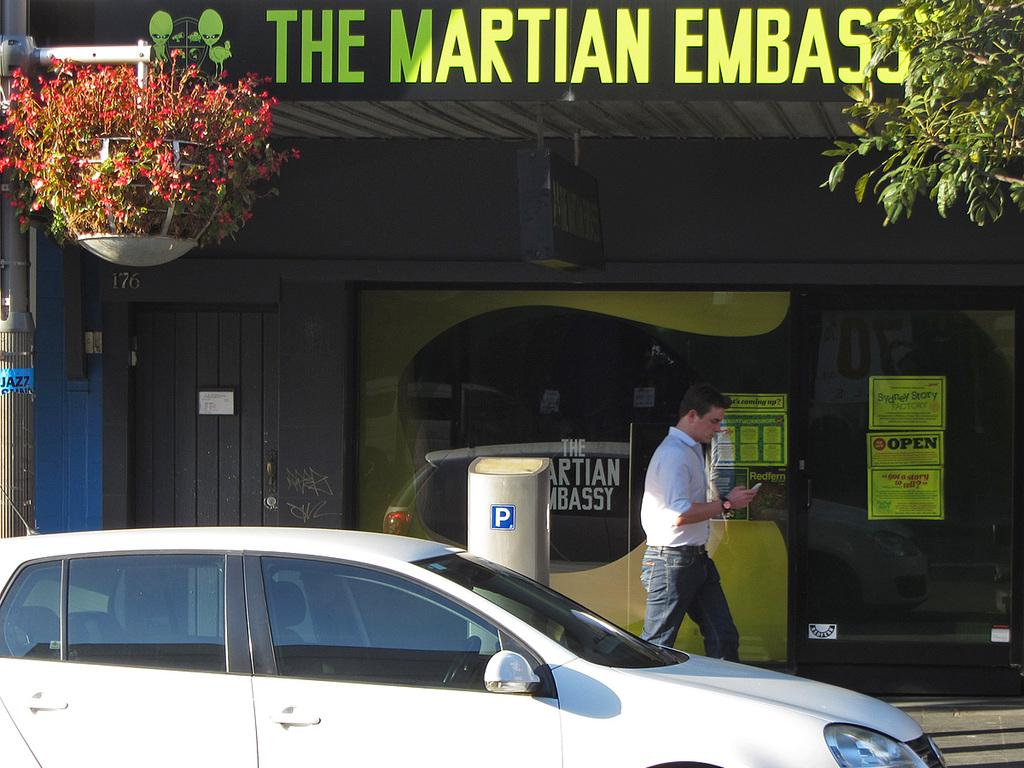What is the main subject of the image? There is a car in the image. What else can be seen in the image besides the car? There is a pole, a plant, flowers, boards, leaves, and a person in the image. Can you describe the background of the image? In the background, there is a door, a wall, and posters. What type of linen is being used to cover the railway tracks in the image? There is no linen or railway tracks present in the image. Can you tell me how many soldiers are visible in the army uniforms in the image? There are no soldiers or army uniforms present in the image. 